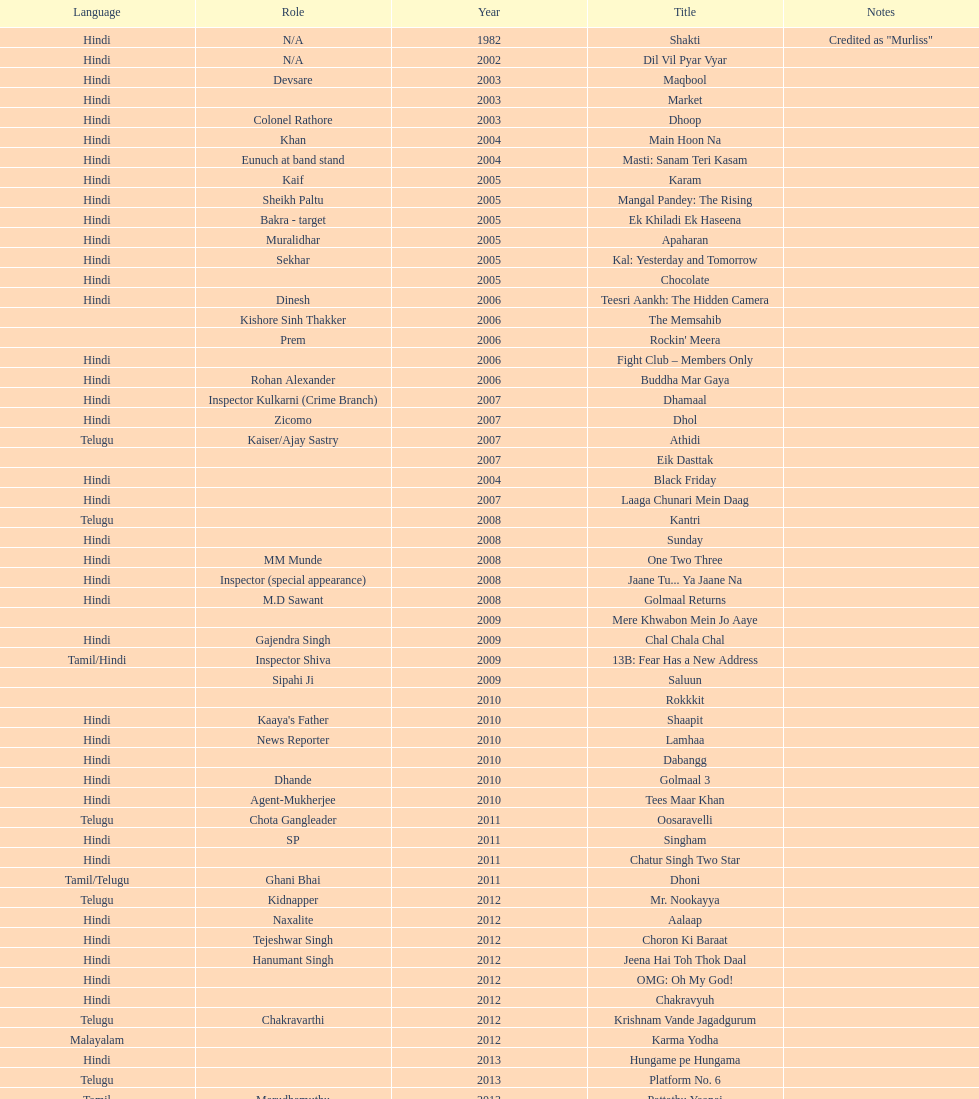What was the last malayalam film this actor starred in? Karma Yodha. I'm looking to parse the entire table for insights. Could you assist me with that? {'header': ['Language', 'Role', 'Year', 'Title', 'Notes'], 'rows': [['Hindi', 'N/A', '1982', 'Shakti', 'Credited as "Murliss"'], ['Hindi', 'N/A', '2002', 'Dil Vil Pyar Vyar', ''], ['Hindi', 'Devsare', '2003', 'Maqbool', ''], ['Hindi', '', '2003', 'Market', ''], ['Hindi', 'Colonel Rathore', '2003', 'Dhoop', ''], ['Hindi', 'Khan', '2004', 'Main Hoon Na', ''], ['Hindi', 'Eunuch at band stand', '2004', 'Masti: Sanam Teri Kasam', ''], ['Hindi', 'Kaif', '2005', 'Karam', ''], ['Hindi', 'Sheikh Paltu', '2005', 'Mangal Pandey: The Rising', ''], ['Hindi', 'Bakra - target', '2005', 'Ek Khiladi Ek Haseena', ''], ['Hindi', 'Muralidhar', '2005', 'Apaharan', ''], ['Hindi', 'Sekhar', '2005', 'Kal: Yesterday and Tomorrow', ''], ['Hindi', '', '2005', 'Chocolate', ''], ['Hindi', 'Dinesh', '2006', 'Teesri Aankh: The Hidden Camera', ''], ['', 'Kishore Sinh Thakker', '2006', 'The Memsahib', ''], ['', 'Prem', '2006', "Rockin' Meera", ''], ['Hindi', '', '2006', 'Fight Club – Members Only', ''], ['Hindi', 'Rohan Alexander', '2006', 'Buddha Mar Gaya', ''], ['Hindi', 'Inspector Kulkarni (Crime Branch)', '2007', 'Dhamaal', ''], ['Hindi', 'Zicomo', '2007', 'Dhol', ''], ['Telugu', 'Kaiser/Ajay Sastry', '2007', 'Athidi', ''], ['', '', '2007', 'Eik Dasttak', ''], ['Hindi', '', '2004', 'Black Friday', ''], ['Hindi', '', '2007', 'Laaga Chunari Mein Daag', ''], ['Telugu', '', '2008', 'Kantri', ''], ['Hindi', '', '2008', 'Sunday', ''], ['Hindi', 'MM Munde', '2008', 'One Two Three', ''], ['Hindi', 'Inspector (special appearance)', '2008', 'Jaane Tu... Ya Jaane Na', ''], ['Hindi', 'M.D Sawant', '2008', 'Golmaal Returns', ''], ['', '', '2009', 'Mere Khwabon Mein Jo Aaye', ''], ['Hindi', 'Gajendra Singh', '2009', 'Chal Chala Chal', ''], ['Tamil/Hindi', 'Inspector Shiva', '2009', '13B: Fear Has a New Address', ''], ['', 'Sipahi Ji', '2009', 'Saluun', ''], ['', '', '2010', 'Rokkkit', ''], ['Hindi', "Kaaya's Father", '2010', 'Shaapit', ''], ['Hindi', 'News Reporter', '2010', 'Lamhaa', ''], ['Hindi', '', '2010', 'Dabangg', ''], ['Hindi', 'Dhande', '2010', 'Golmaal 3', ''], ['Hindi', 'Agent-Mukherjee', '2010', 'Tees Maar Khan', ''], ['Telugu', 'Chota Gangleader', '2011', 'Oosaravelli', ''], ['Hindi', 'SP', '2011', 'Singham', ''], ['Hindi', '', '2011', 'Chatur Singh Two Star', ''], ['Tamil/Telugu', 'Ghani Bhai', '2011', 'Dhoni', ''], ['Telugu', 'Kidnapper', '2012', 'Mr. Nookayya', ''], ['Hindi', 'Naxalite', '2012', 'Aalaap', ''], ['Hindi', 'Tejeshwar Singh', '2012', 'Choron Ki Baraat', ''], ['Hindi', 'Hanumant Singh', '2012', 'Jeena Hai Toh Thok Daal', ''], ['Hindi', '', '2012', 'OMG: Oh My God!', ''], ['Hindi', '', '2012', 'Chakravyuh', ''], ['Telugu', 'Chakravarthi', '2012', 'Krishnam Vande Jagadgurum', ''], ['Malayalam', '', '2012', 'Karma Yodha', ''], ['Hindi', '', '2013', 'Hungame pe Hungama', ''], ['Telugu', '', '2013', 'Platform No. 6', ''], ['Tamil', 'Marudhamuthu', '2013', 'Pattathu Yaanai', ''], ['Hindi', '', '2013', 'Zindagi 50-50', ''], ['Telugu', 'Durani', '2013', 'Yevadu', ''], ['Telugu', '', '2013', 'Karmachari', '']]} 